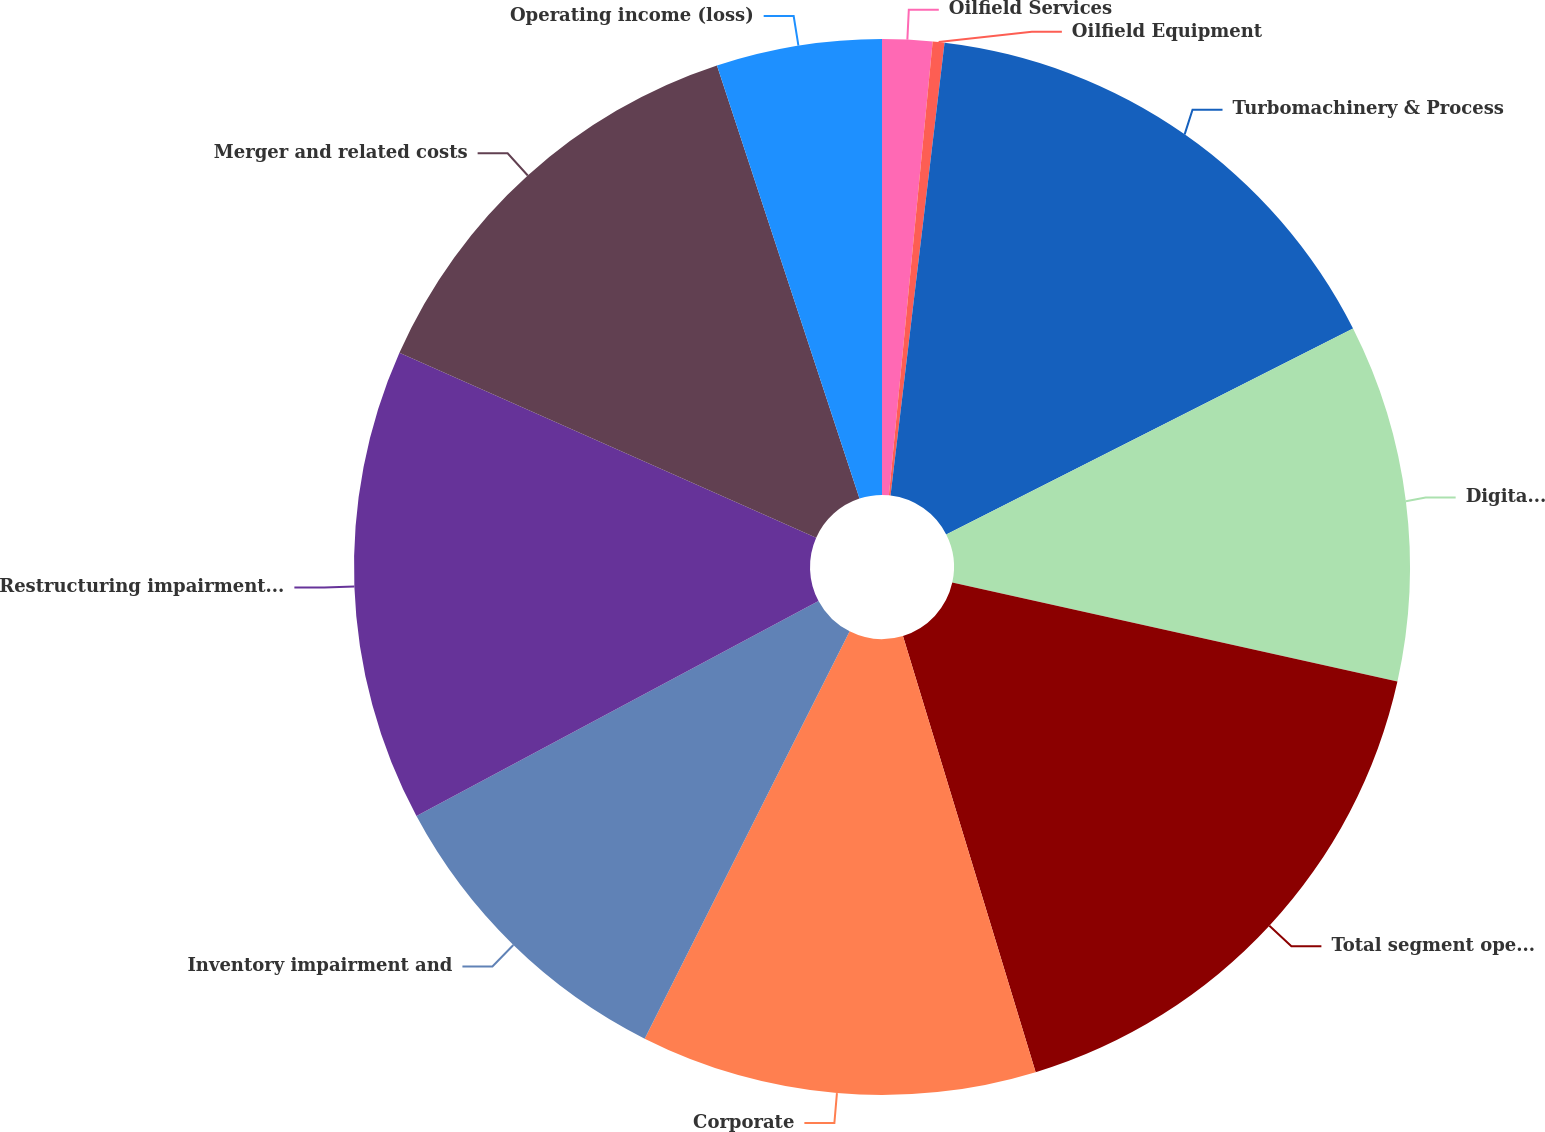Convert chart. <chart><loc_0><loc_0><loc_500><loc_500><pie_chart><fcel>Oilfield Services<fcel>Oilfield Equipment<fcel>Turbomachinery & Process<fcel>Digital Solutions<fcel>Total segment operating income<fcel>Corporate<fcel>Inventory impairment and<fcel>Restructuring impairment and<fcel>Merger and related costs<fcel>Operating income (loss)<nl><fcel>1.53%<fcel>0.36%<fcel>15.65%<fcel>10.94%<fcel>16.82%<fcel>12.12%<fcel>9.76%<fcel>14.47%<fcel>13.29%<fcel>5.06%<nl></chart> 